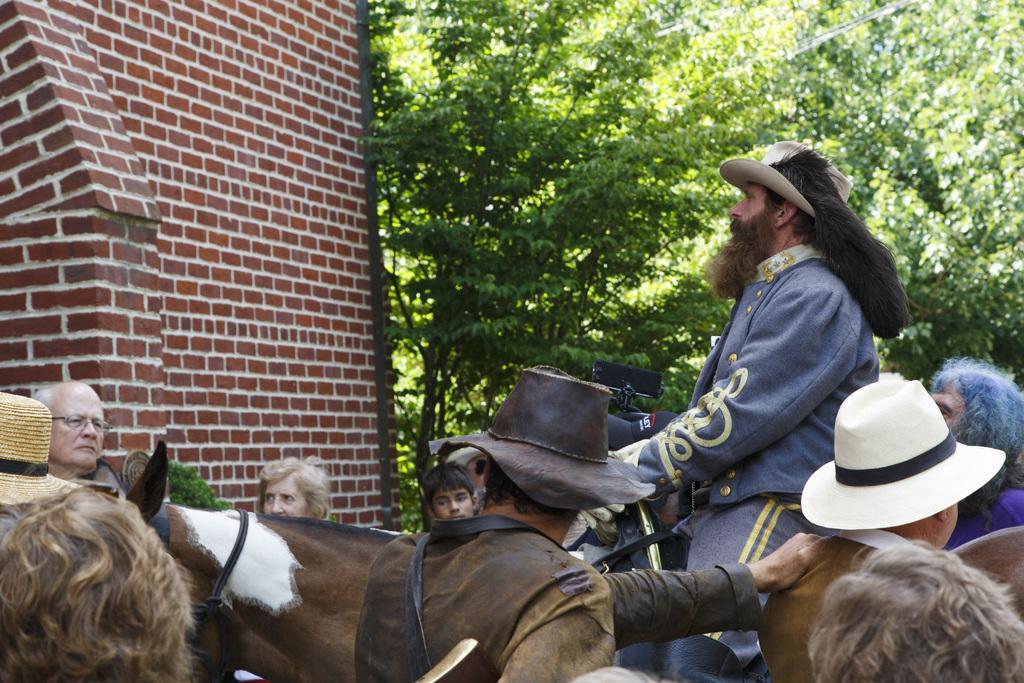Please provide a concise description of this image. In this image I can see horse, people, trees, brick wall and an object. Among these people one person is sitting on the horse and few people wore hats.   